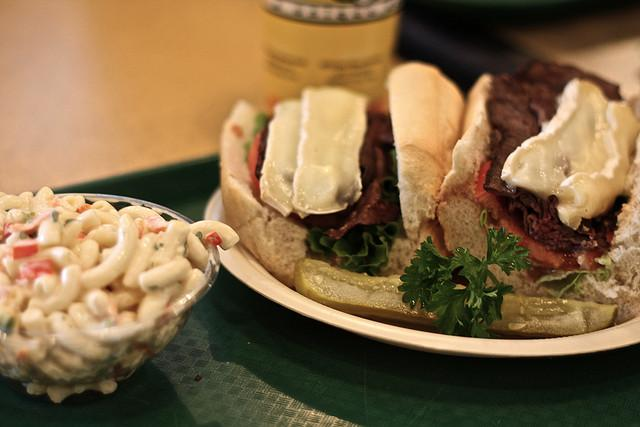What kind of pasta is on the left? Please explain your reasoning. macaroni. The dish on the left is a traditional macaroni salad. 